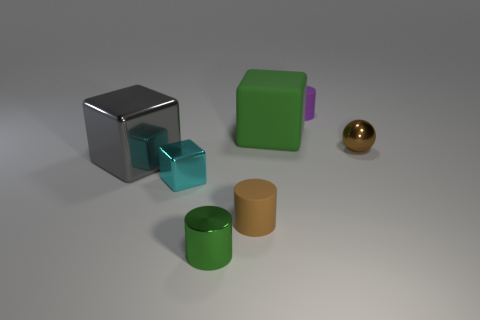How many other objects are the same material as the small purple cylinder?
Ensure brevity in your answer.  2. Is the sphere made of the same material as the big thing right of the large metal block?
Keep it short and to the point. No. How many things are either small matte cylinders that are in front of the tiny metal sphere or small objects that are in front of the brown metal ball?
Give a very brief answer. 3. What number of other things are there of the same color as the matte block?
Your answer should be very brief. 1. Is the number of matte objects in front of the small purple thing greater than the number of gray objects that are left of the cyan metal block?
Give a very brief answer. Yes. How many cylinders are tiny brown matte things or green metal objects?
Keep it short and to the point. 2. What number of objects are small rubber things that are on the left side of the green matte thing or big brown blocks?
Make the answer very short. 1. There is a big object in front of the brown shiny ball to the right of the tiny cyan metal block that is on the left side of the small brown cylinder; what is its shape?
Your answer should be very brief. Cube. What number of rubber objects are the same shape as the green metallic object?
Ensure brevity in your answer.  2. What material is the object that is the same color as the tiny sphere?
Offer a very short reply. Rubber. 